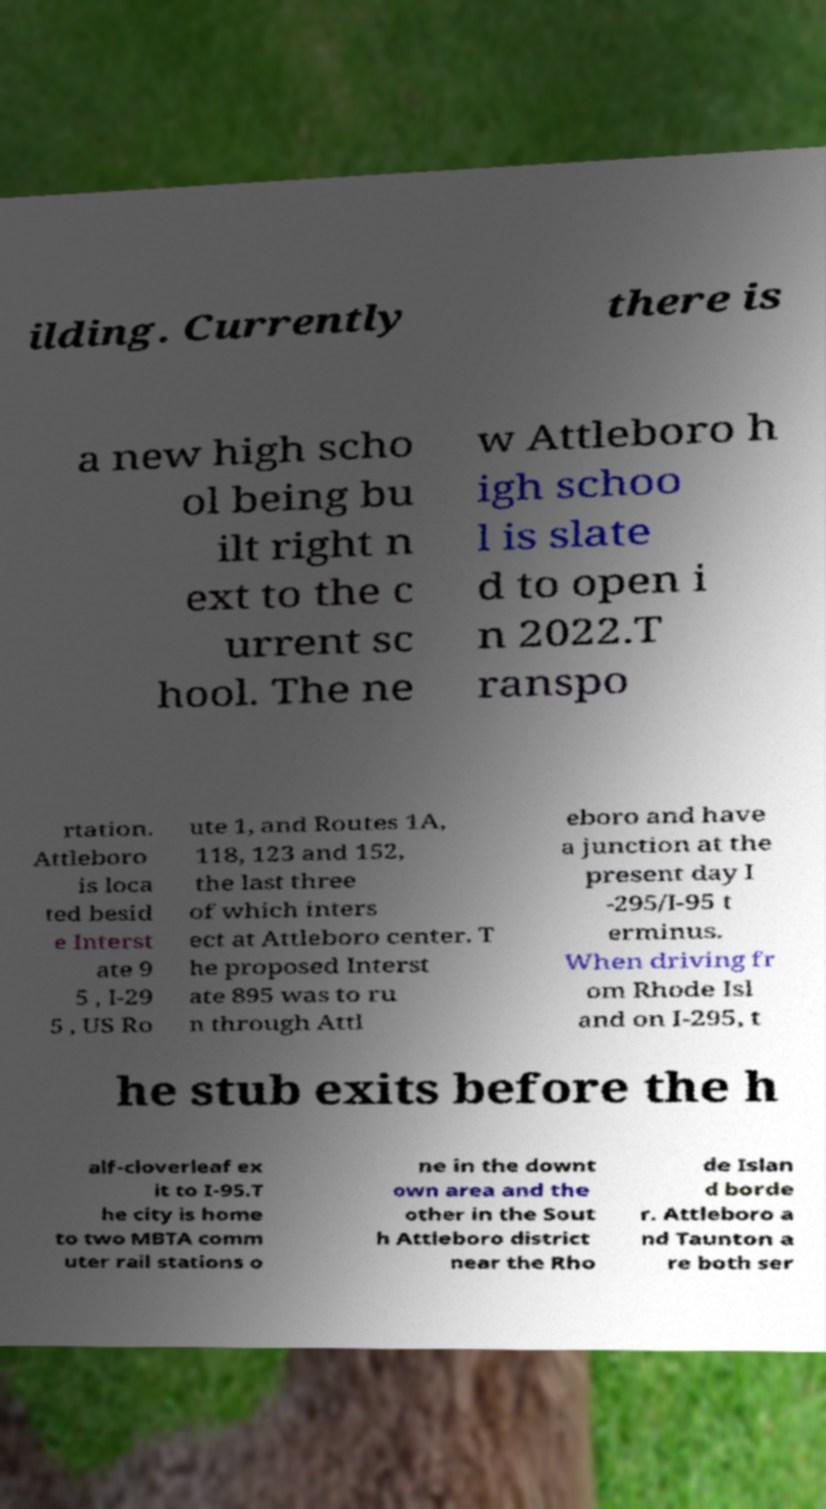There's text embedded in this image that I need extracted. Can you transcribe it verbatim? ilding. Currently there is a new high scho ol being bu ilt right n ext to the c urrent sc hool. The ne w Attleboro h igh schoo l is slate d to open i n 2022.T ranspo rtation. Attleboro is loca ted besid e Interst ate 9 5 , I-29 5 , US Ro ute 1, and Routes 1A, 118, 123 and 152, the last three of which inters ect at Attleboro center. T he proposed Interst ate 895 was to ru n through Attl eboro and have a junction at the present day I -295/I-95 t erminus. When driving fr om Rhode Isl and on I-295, t he stub exits before the h alf-cloverleaf ex it to I-95.T he city is home to two MBTA comm uter rail stations o ne in the downt own area and the other in the Sout h Attleboro district near the Rho de Islan d borde r. Attleboro a nd Taunton a re both ser 